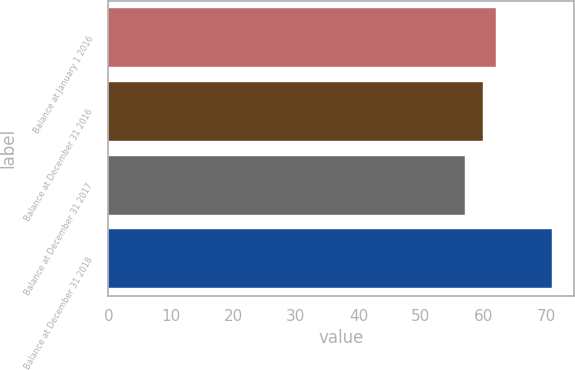<chart> <loc_0><loc_0><loc_500><loc_500><bar_chart><fcel>Balance at January 1 2016<fcel>Balance at December 31 2016<fcel>Balance at December 31 2017<fcel>Balance at December 31 2018<nl><fcel>62<fcel>60<fcel>57<fcel>71<nl></chart> 